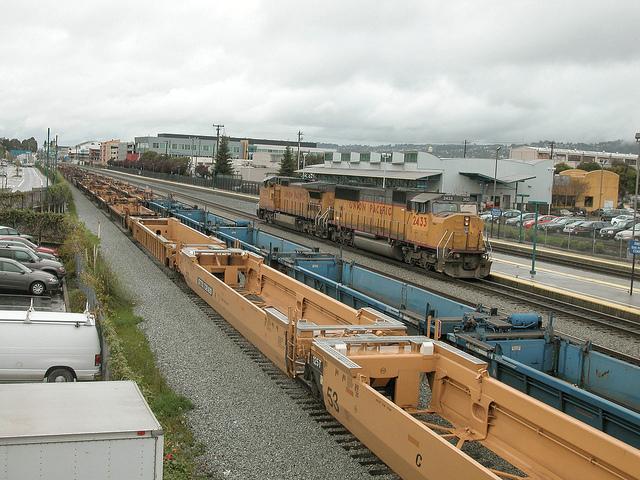How many blue trains are there?
Give a very brief answer. 5. How many trains are there?
Give a very brief answer. 3. 